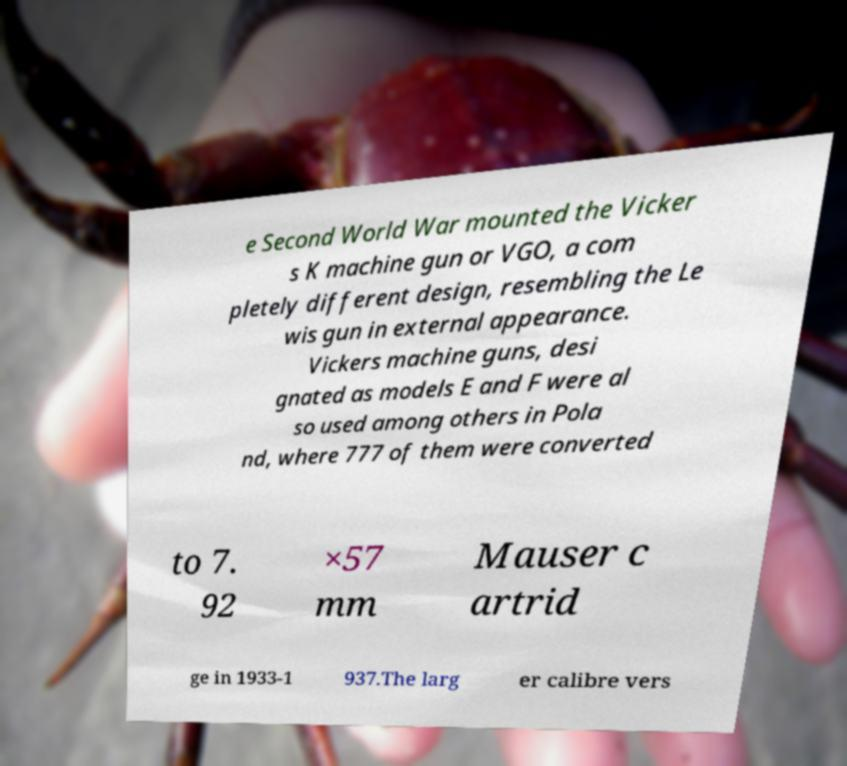Can you accurately transcribe the text from the provided image for me? e Second World War mounted the Vicker s K machine gun or VGO, a com pletely different design, resembling the Le wis gun in external appearance. Vickers machine guns, desi gnated as models E and F were al so used among others in Pola nd, where 777 of them were converted to 7. 92 ×57 mm Mauser c artrid ge in 1933-1 937.The larg er calibre vers 